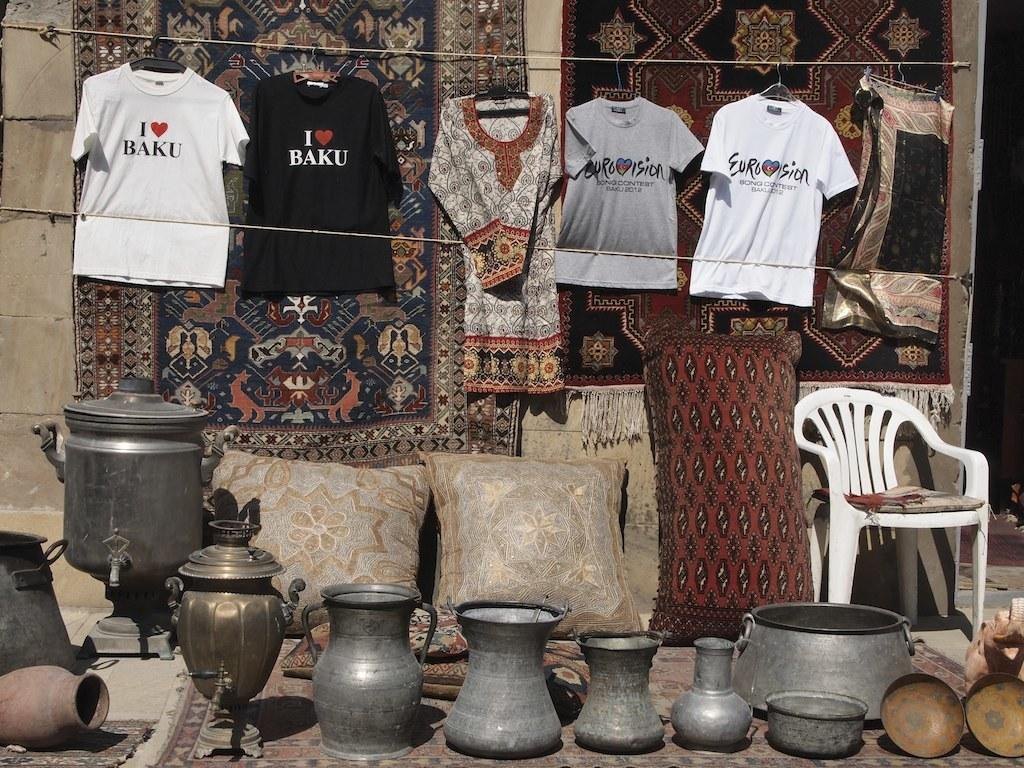<image>
Create a compact narrative representing the image presented. A t shirt with "I love Baku" hangs from a line. 